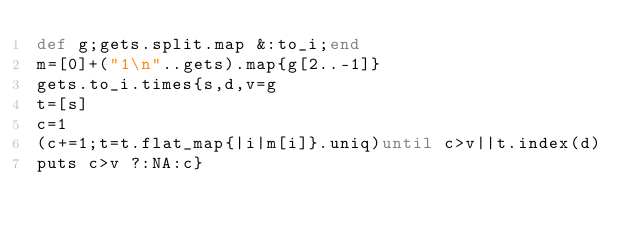Convert code to text. <code><loc_0><loc_0><loc_500><loc_500><_Ruby_>def g;gets.split.map &:to_i;end
m=[0]+("1\n"..gets).map{g[2..-1]}
gets.to_i.times{s,d,v=g
t=[s]
c=1
(c+=1;t=t.flat_map{|i|m[i]}.uniq)until c>v||t.index(d)
puts c>v ?:NA:c}</code> 